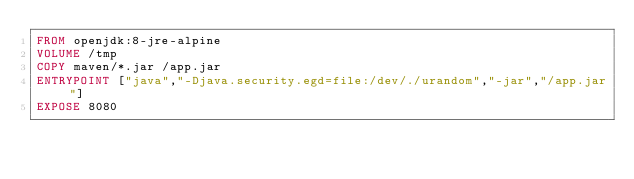<code> <loc_0><loc_0><loc_500><loc_500><_Dockerfile_>FROM openjdk:8-jre-alpine
VOLUME /tmp
COPY maven/*.jar /app.jar
ENTRYPOINT ["java","-Djava.security.egd=file:/dev/./urandom","-jar","/app.jar"]
EXPOSE 8080</code> 